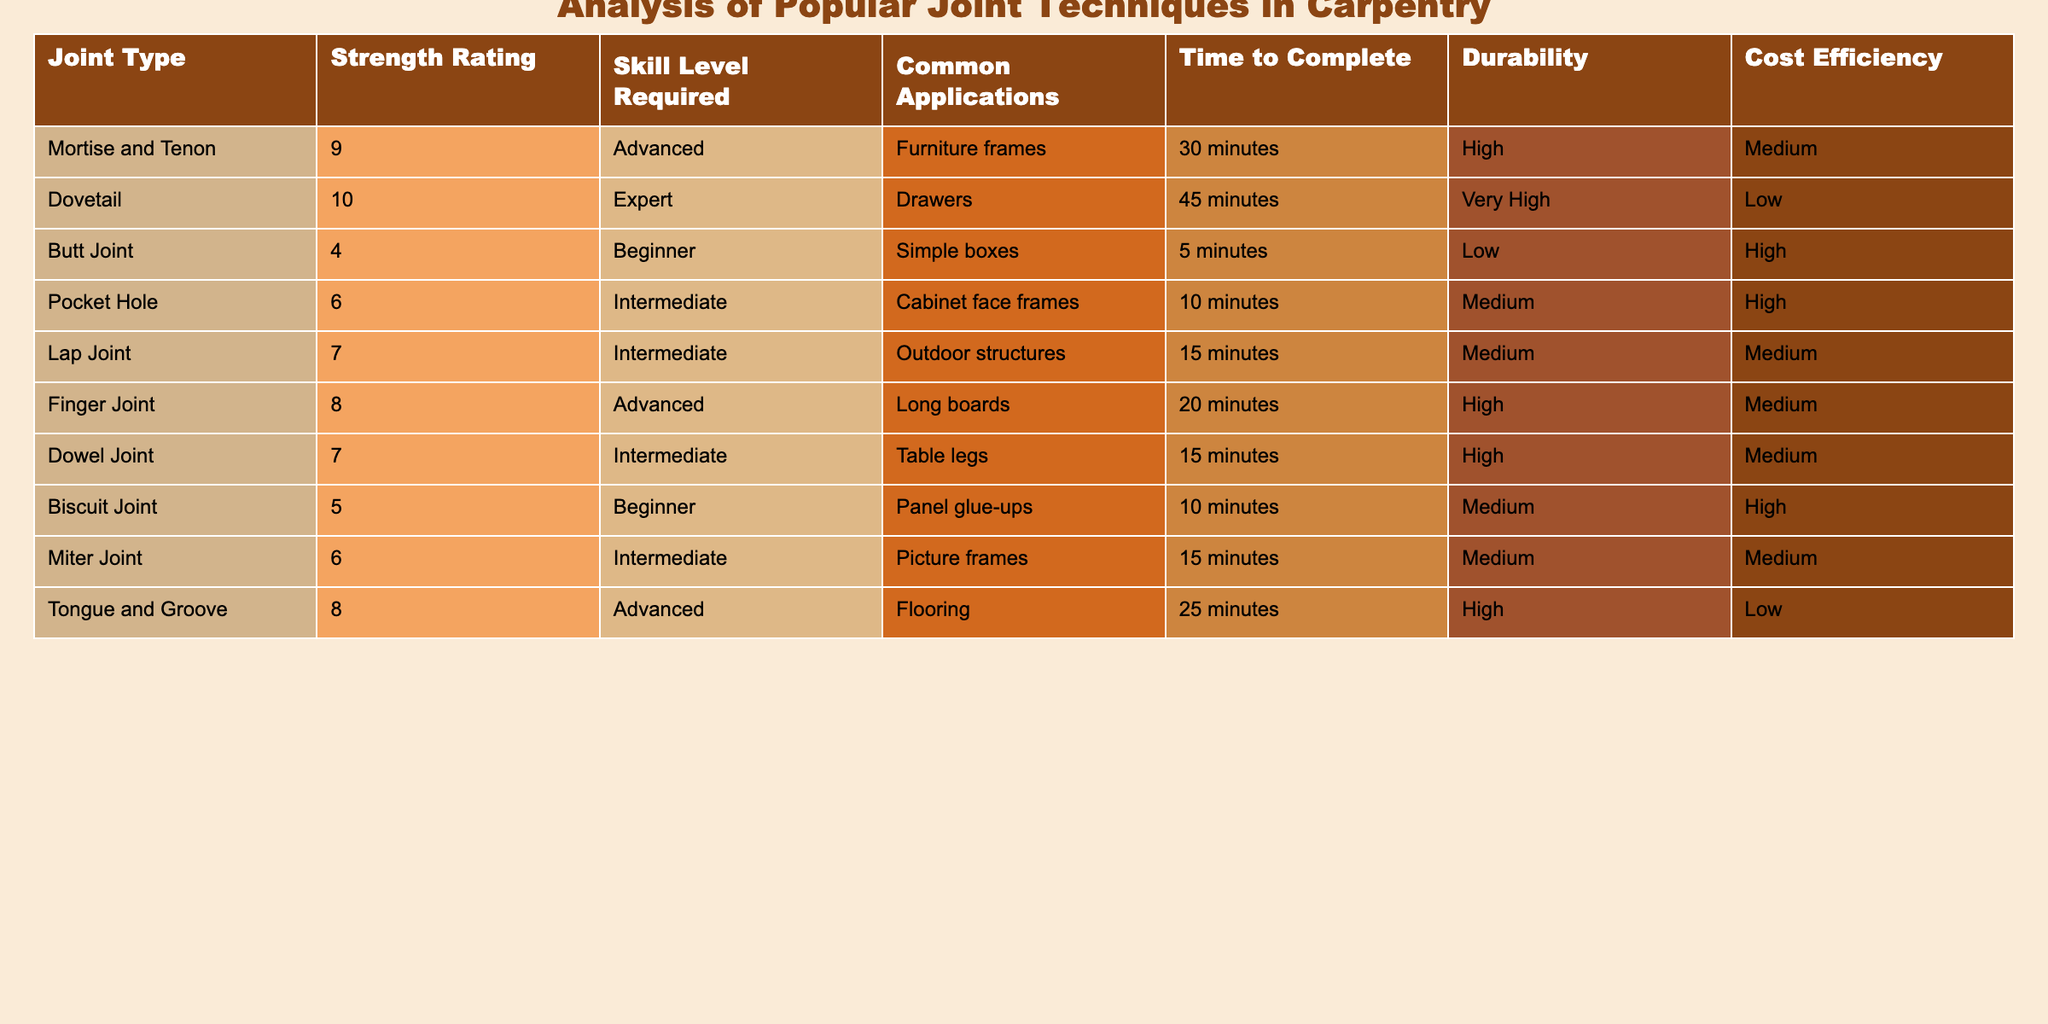What is the strength rating of the Dovetail joint? The Dovetail joint has a strength rating listed in the table, which is 10.
Answer: 10 How many joint types have a durability rating of "High"? By checking the "Durability" column, the joint types with a "High" rating are Mortise and Tenon, Dowel Joint, and Biscuit Joint. There are 3 of them.
Answer: 3 What is the time to complete a Pocket Hole joint? The table lists the time to complete a Pocket Hole joint as 10 minutes.
Answer: 10 minutes Which joint type requires the highest skill level? The joint with the highest skill level required is the Dovetail joint, which is rated as "Expert."
Answer: Dovetail What is the average strength rating of all joint types? To find the average strength rating, add all the strength ratings (9 + 10 + 4 + 6 + 7 + 8 + 7 + 5 + 6 + 8 = 70), and then divide by the number of joint types (10). This gives an average of 70/10 = 7.
Answer: 7 Is a Butt Joint considered durable? The durability rating for a Butt Joint is "Low," indicating that it is not considered durable.
Answer: No Which joint types have a skill level of "Intermediate"? The joint types with an "Intermediate" skill level are Pocket Hole, Lap Joint, and Miter Joint.
Answer: Pocket Hole, Lap Joint, Miter Joint What is the difference in average time to complete between advanced joints and beginner joints? The advanced joints are Mortise and Tenon, Dovetail, Finger Joint, and Tongue and Groove (30 + 45 + 20 + 25 = 120 minutes; average 120/4 = 30). The beginner joints are Butt Joint and Biscuit Joint (5 + 10 = 15 minutes; average 15/2 = 7.5). The difference is 30 - 7.5 = 22.5 minutes.
Answer: 22.5 minutes How many joint types have a cost efficiency rating of "Low"? Reviewing the "Cost Efficiency" column, the joint types with a "Low" rating are Dovetail and Tongue and Groove. So, there are 2 joint types that fit this criterion.
Answer: 2 Which joint has a higher strength rating, Finger Joint or Dowel Joint? The Finger Joint has a strength rating of 8, while the Dowel Joint has a rating of 7. Since 8 is greater than 7, the Finger Joint has a higher strength rating.
Answer: Finger Joint 